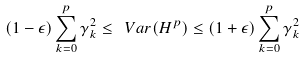<formula> <loc_0><loc_0><loc_500><loc_500>( 1 - \epsilon ) \sum _ { k = 0 } ^ { p } \gamma _ { k } ^ { 2 } \leq \ V a r ( H ^ { p } ) \leq ( 1 + \epsilon ) \sum _ { k = 0 } ^ { p } \gamma _ { k } ^ { 2 }</formula> 